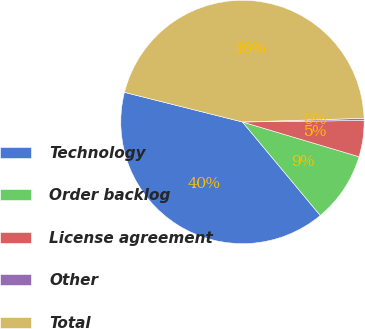Convert chart to OTSL. <chart><loc_0><loc_0><loc_500><loc_500><pie_chart><fcel>Technology<fcel>Order backlog<fcel>License agreement<fcel>Other<fcel>Total<nl><fcel>39.96%<fcel>9.34%<fcel>4.81%<fcel>0.28%<fcel>45.6%<nl></chart> 